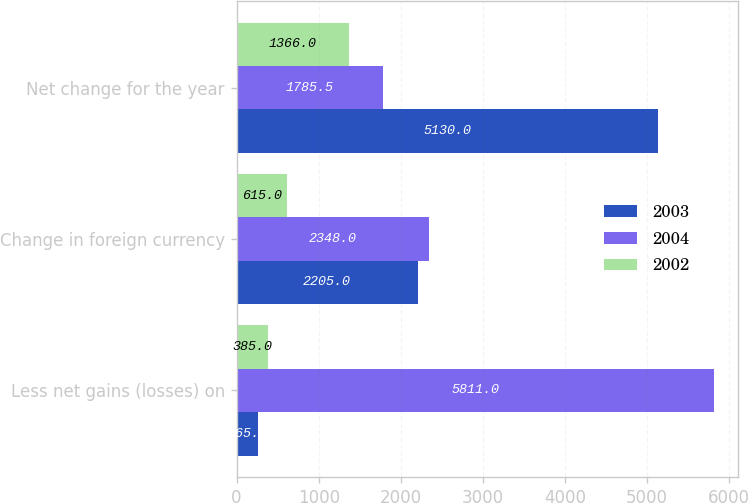Convert chart. <chart><loc_0><loc_0><loc_500><loc_500><stacked_bar_chart><ecel><fcel>Less net gains (losses) on<fcel>Change in foreign currency<fcel>Net change for the year<nl><fcel>2003<fcel>265<fcel>2205<fcel>5130<nl><fcel>2004<fcel>5811<fcel>2348<fcel>1785.5<nl><fcel>2002<fcel>385<fcel>615<fcel>1366<nl></chart> 